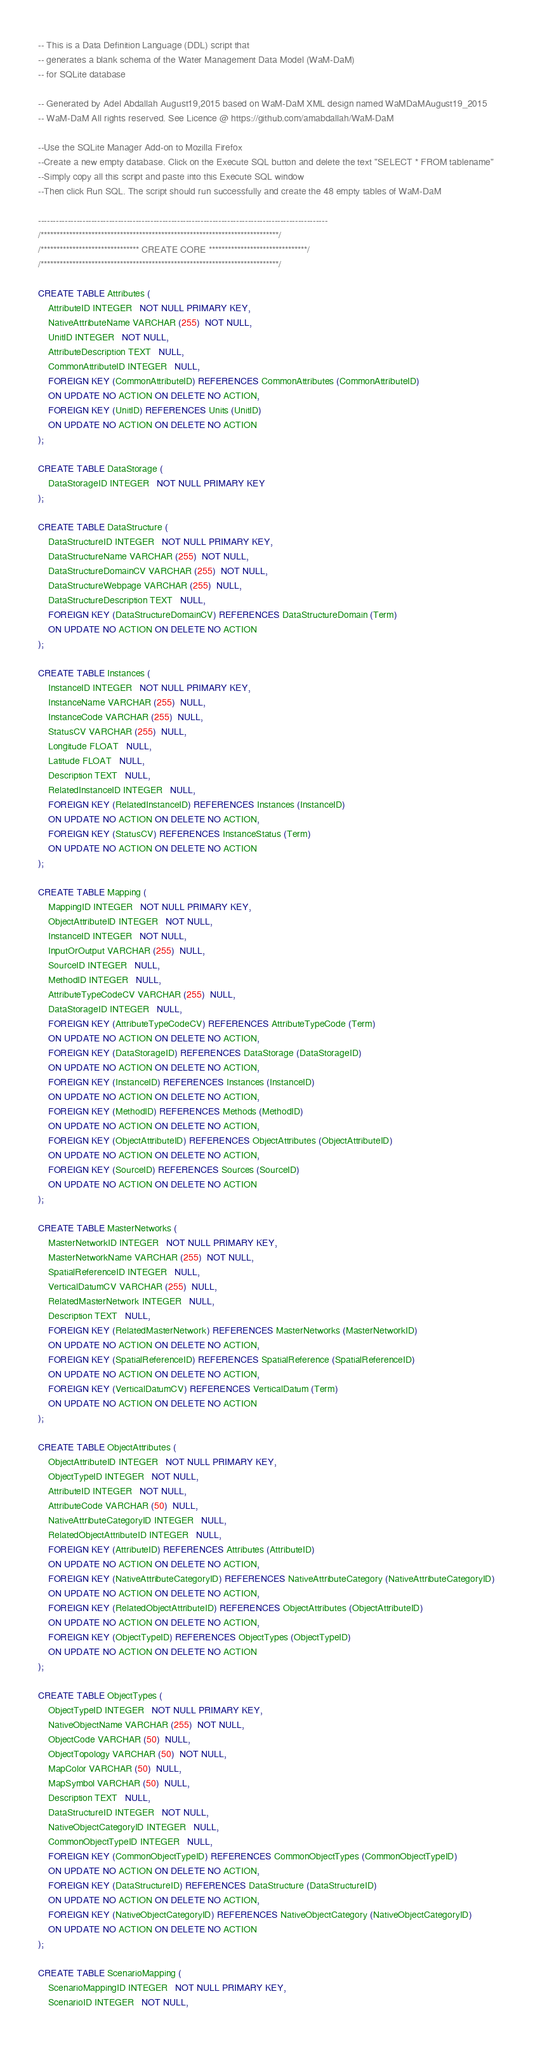<code> <loc_0><loc_0><loc_500><loc_500><_SQL_>-- This is a Data Definition Language (DDL) script that
-- generates a blank schema of the Water Management Data Model (WaM-DaM)
-- for SQLite database

-- Generated by Adel Abdallah August19,2015 based on WaM-DaM XML design named WaMDaMAugust19_2015
-- WaM-DaM All rights reserved. See Licence @ https://github.com/amabdallah/WaM-DaM 

--Use the SQLite Manager Add-on to Mozilla Firefox
--Create a new empty database. Click on the Execute SQL button and delete the text "SELECT * FROM tablename"
--Simply copy all this script and paste into this Execute SQL window
--Then click Run SQL. The script should run successfully and create the 48 empty tables of WaM-DaM

--------------------------------------------------------------------------------------------------
/***************************************************************************/
/******************************* CREATE CORE *******************************/
/***************************************************************************/

CREATE TABLE Attributes (
	AttributeID INTEGER   NOT NULL PRIMARY KEY,
	NativeAttributeName VARCHAR (255)  NOT NULL,
	UnitID INTEGER   NOT NULL,
	AttributeDescription TEXT   NULL,
	CommonAttributeID INTEGER   NULL,
	FOREIGN KEY (CommonAttributeID) REFERENCES CommonAttributes (CommonAttributeID)
	ON UPDATE NO ACTION ON DELETE NO ACTION,
	FOREIGN KEY (UnitID) REFERENCES Units (UnitID)
	ON UPDATE NO ACTION ON DELETE NO ACTION
);

CREATE TABLE DataStorage (
	DataStorageID INTEGER   NOT NULL PRIMARY KEY
);

CREATE TABLE DataStructure (
	DataStructureID INTEGER   NOT NULL PRIMARY KEY,
	DataStructureName VARCHAR (255)  NOT NULL,
	DataStructureDomainCV VARCHAR (255)  NOT NULL,
	DataStructureWebpage VARCHAR (255)  NULL,
	DataStructureDescription TEXT   NULL,
	FOREIGN KEY (DataStructureDomainCV) REFERENCES DataStructureDomain (Term)
	ON UPDATE NO ACTION ON DELETE NO ACTION
);

CREATE TABLE Instances (
	InstanceID INTEGER   NOT NULL PRIMARY KEY,
	InstanceName VARCHAR (255)  NULL,
	InstanceCode VARCHAR (255)  NULL,
	StatusCV VARCHAR (255)  NULL,
	Longitude FLOAT   NULL,
	Latitude FLOAT   NULL,
	Description TEXT   NULL,
	RelatedInstanceID INTEGER   NULL,
	FOREIGN KEY (RelatedInstanceID) REFERENCES Instances (InstanceID)
	ON UPDATE NO ACTION ON DELETE NO ACTION,
	FOREIGN KEY (StatusCV) REFERENCES InstanceStatus (Term)
	ON UPDATE NO ACTION ON DELETE NO ACTION
);

CREATE TABLE Mapping (
	MappingID INTEGER   NOT NULL PRIMARY KEY,
	ObjectAttributeID INTEGER   NOT NULL,
	InstanceID INTEGER   NOT NULL,
	InputOrOutput VARCHAR (255)  NULL,
	SourceID INTEGER   NULL,
	MethodID INTEGER   NULL,
	AttributeTypeCodeCV VARCHAR (255)  NULL,
	DataStorageID INTEGER   NULL,
	FOREIGN KEY (AttributeTypeCodeCV) REFERENCES AttributeTypeCode (Term)
	ON UPDATE NO ACTION ON DELETE NO ACTION,
	FOREIGN KEY (DataStorageID) REFERENCES DataStorage (DataStorageID)
	ON UPDATE NO ACTION ON DELETE NO ACTION,
	FOREIGN KEY (InstanceID) REFERENCES Instances (InstanceID)
	ON UPDATE NO ACTION ON DELETE NO ACTION,
	FOREIGN KEY (MethodID) REFERENCES Methods (MethodID)
	ON UPDATE NO ACTION ON DELETE NO ACTION,
	FOREIGN KEY (ObjectAttributeID) REFERENCES ObjectAttributes (ObjectAttributeID)
	ON UPDATE NO ACTION ON DELETE NO ACTION,
	FOREIGN KEY (SourceID) REFERENCES Sources (SourceID)
	ON UPDATE NO ACTION ON DELETE NO ACTION
);

CREATE TABLE MasterNetworks (
	MasterNetworkID INTEGER   NOT NULL PRIMARY KEY,
	MasterNetworkName VARCHAR (255)  NOT NULL,
	SpatialReferenceID INTEGER   NULL,
	VerticalDatumCV VARCHAR (255)  NULL,
	RelatedMasterNetwork INTEGER   NULL,
	Description TEXT   NULL,
	FOREIGN KEY (RelatedMasterNetwork) REFERENCES MasterNetworks (MasterNetworkID)
	ON UPDATE NO ACTION ON DELETE NO ACTION,
	FOREIGN KEY (SpatialReferenceID) REFERENCES SpatialReference (SpatialReferenceID)
	ON UPDATE NO ACTION ON DELETE NO ACTION,
	FOREIGN KEY (VerticalDatumCV) REFERENCES VerticalDatum (Term)
	ON UPDATE NO ACTION ON DELETE NO ACTION
);

CREATE TABLE ObjectAttributes (
	ObjectAttributeID INTEGER   NOT NULL PRIMARY KEY,
	ObjectTypeID INTEGER   NOT NULL,
	AttributeID INTEGER   NOT NULL,
	AttributeCode VARCHAR (50)  NULL,
	NativeAttributeCategoryID INTEGER   NULL,
	RelatedObjectAttributeID INTEGER   NULL,
	FOREIGN KEY (AttributeID) REFERENCES Attributes (AttributeID)
	ON UPDATE NO ACTION ON DELETE NO ACTION,
	FOREIGN KEY (NativeAttributeCategoryID) REFERENCES NativeAttributeCategory (NativeAttributeCategoryID)
	ON UPDATE NO ACTION ON DELETE NO ACTION,
	FOREIGN KEY (RelatedObjectAttributeID) REFERENCES ObjectAttributes (ObjectAttributeID)
	ON UPDATE NO ACTION ON DELETE NO ACTION,
	FOREIGN KEY (ObjectTypeID) REFERENCES ObjectTypes (ObjectTypeID)
	ON UPDATE NO ACTION ON DELETE NO ACTION
);

CREATE TABLE ObjectTypes (
	ObjectTypeID INTEGER   NOT NULL PRIMARY KEY,
	NativeObjectName VARCHAR (255)  NOT NULL,
	ObjectCode VARCHAR (50)  NULL,
	ObjectTopology VARCHAR (50)  NOT NULL,
	MapColor VARCHAR (50)  NULL,
	MapSymbol VARCHAR (50)  NULL,
	Description TEXT   NULL,
	DataStructureID INTEGER   NOT NULL,
	NativeObjectCategoryID INTEGER   NULL,
	CommonObjectTypeID INTEGER   NULL,
	FOREIGN KEY (CommonObjectTypeID) REFERENCES CommonObjectTypes (CommonObjectTypeID)
	ON UPDATE NO ACTION ON DELETE NO ACTION,
	FOREIGN KEY (DataStructureID) REFERENCES DataStructure (DataStructureID)
	ON UPDATE NO ACTION ON DELETE NO ACTION,
	FOREIGN KEY (NativeObjectCategoryID) REFERENCES NativeObjectCategory (NativeObjectCategoryID)
	ON UPDATE NO ACTION ON DELETE NO ACTION
);

CREATE TABLE ScenarioMapping (
	ScenarioMappingID INTEGER   NOT NULL PRIMARY KEY,
	ScenarioID INTEGER   NOT NULL,</code> 